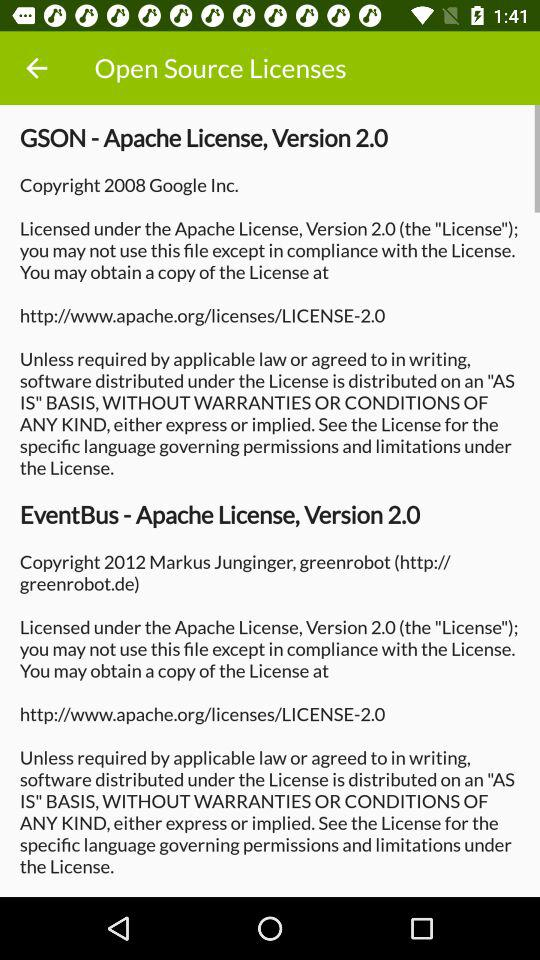How many licenses are licensed under the Apache License, Version 2.0?
Answer the question using a single word or phrase. 2 